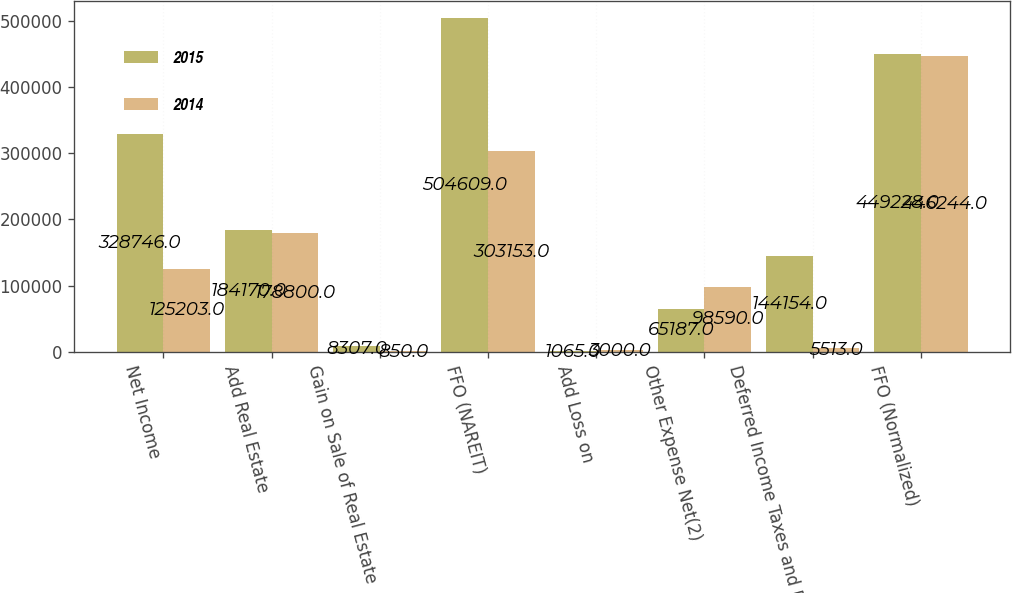Convert chart to OTSL. <chart><loc_0><loc_0><loc_500><loc_500><stacked_bar_chart><ecel><fcel>Net Income<fcel>Add Real Estate<fcel>Gain on Sale of Real Estate<fcel>FFO (NAREIT)<fcel>Add Loss on<fcel>Other Expense Net(2)<fcel>Deferred Income Taxes and REIT<fcel>FFO (Normalized)<nl><fcel>2015<fcel>328746<fcel>184170<fcel>8307<fcel>504609<fcel>1065<fcel>65187<fcel>144154<fcel>449228<nl><fcel>2014<fcel>125203<fcel>178800<fcel>850<fcel>303153<fcel>3000<fcel>98590<fcel>5513<fcel>446244<nl></chart> 